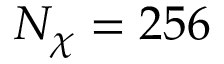Convert formula to latex. <formula><loc_0><loc_0><loc_500><loc_500>N _ { \chi } = 2 5 6</formula> 